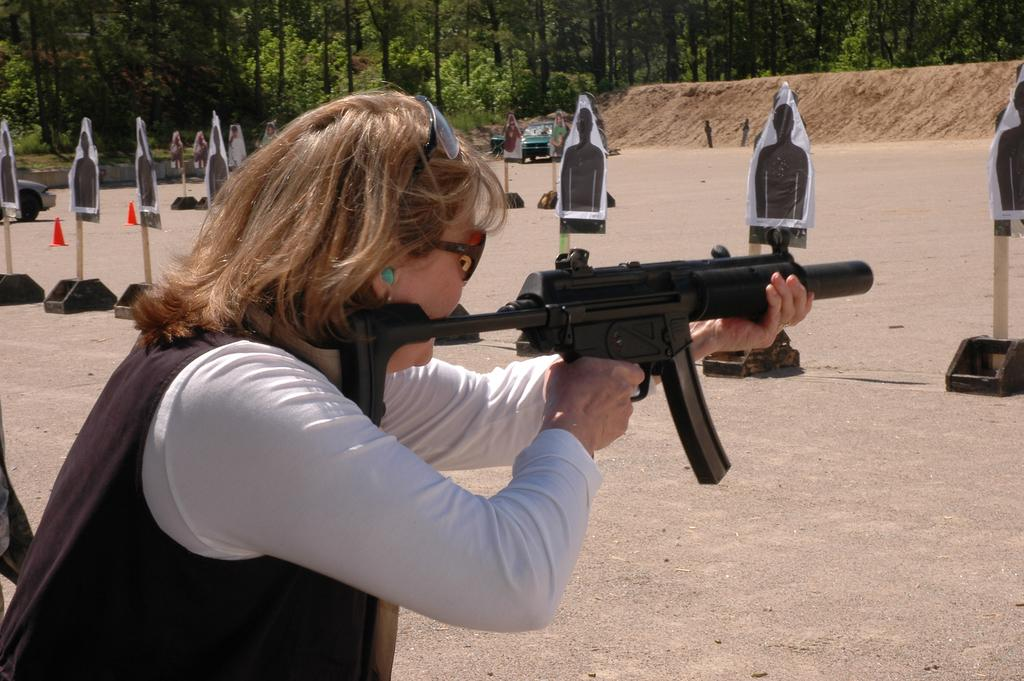What is the person in the image holding? The person is holding a gun in the image. What is the person doing with the gun? The person is shooting at a target in the image. How many targets can be seen in the image? There are targets in the image. What other objects are present in the image? There are cones, trees, a vehicle, and sand visible in the image. Can you tell me how many islands are visible in the image? There are no islands visible in the image. What type of self-care activity is the person engaging in the image? The person is not engaging in a self-care activity in the image; they are shooting at a target with a gun. 